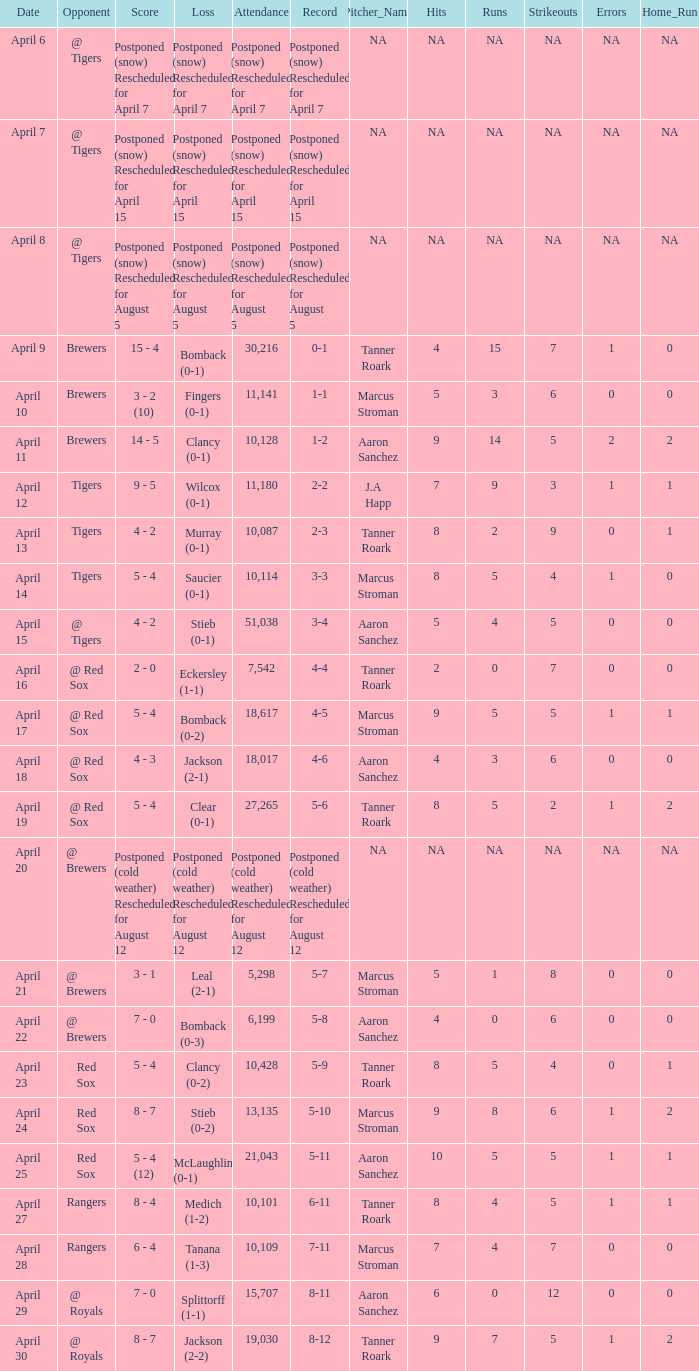Can you give me this table as a dict? {'header': ['Date', 'Opponent', 'Score', 'Loss', 'Attendance', 'Record', 'Pitcher_Name', 'Hits', 'Runs', 'Strikeouts', 'Errors', 'Home_Run'], 'rows': [['April 6', '@ Tigers', 'Postponed (snow) Rescheduled for April 7', 'Postponed (snow) Rescheduled for April 7', 'Postponed (snow) Rescheduled for April 7', 'Postponed (snow) Rescheduled for April 7', 'NA', 'NA', 'NA', 'NA', 'NA', 'NA'], ['April 7', '@ Tigers', 'Postponed (snow) Rescheduled for April 15', 'Postponed (snow) Rescheduled for April 15', 'Postponed (snow) Rescheduled for April 15', 'Postponed (snow) Rescheduled for April 15', 'NA', 'NA', 'NA', 'NA', 'NA', 'NA'], ['April 8', '@ Tigers', 'Postponed (snow) Rescheduled for August 5', 'Postponed (snow) Rescheduled for August 5', 'Postponed (snow) Rescheduled for August 5', 'Postponed (snow) Rescheduled for August 5', 'NA', 'NA', 'NA', 'NA', 'NA', 'NA'], ['April 9', 'Brewers', '15 - 4', 'Bomback (0-1)', '30,216', '0-1', 'Tanner Roark', '4', '15', '7', '1', '0'], ['April 10', 'Brewers', '3 - 2 (10)', 'Fingers (0-1)', '11,141', '1-1', 'Marcus Stroman', '5', '3', '6', '0', '0'], ['April 11', 'Brewers', '14 - 5', 'Clancy (0-1)', '10,128', '1-2', 'Aaron Sanchez', '9', '14', '5', '2', '2'], ['April 12', 'Tigers', '9 - 5', 'Wilcox (0-1)', '11,180', '2-2', 'J.A Happ', '7', '9', '3', '1', '1'], ['April 13', 'Tigers', '4 - 2', 'Murray (0-1)', '10,087', '2-3', 'Tanner Roark', '8', '2', '9', '0', '1'], ['April 14', 'Tigers', '5 - 4', 'Saucier (0-1)', '10,114', '3-3', 'Marcus Stroman', '8', '5', '4', '1', '0'], ['April 15', '@ Tigers', '4 - 2', 'Stieb (0-1)', '51,038', '3-4', 'Aaron Sanchez', '5', '4', '5', '0', '0'], ['April 16', '@ Red Sox', '2 - 0', 'Eckersley (1-1)', '7,542', '4-4', 'Tanner Roark', '2', '0', '7', '0', '0'], ['April 17', '@ Red Sox', '5 - 4', 'Bomback (0-2)', '18,617', '4-5', 'Marcus Stroman', '9', '5', '5', '1', '1'], ['April 18', '@ Red Sox', '4 - 3', 'Jackson (2-1)', '18,017', '4-6', 'Aaron Sanchez', '4', '3', '6', '0', '0'], ['April 19', '@ Red Sox', '5 - 4', 'Clear (0-1)', '27,265', '5-6', 'Tanner Roark', '8', '5', '2', '1', '2'], ['April 20', '@ Brewers', 'Postponed (cold weather) Rescheduled for August 12', 'Postponed (cold weather) Rescheduled for August 12', 'Postponed (cold weather) Rescheduled for August 12', 'Postponed (cold weather) Rescheduled for August 12', 'NA', 'NA', 'NA', 'NA', 'NA', 'NA'], ['April 21', '@ Brewers', '3 - 1', 'Leal (2-1)', '5,298', '5-7', 'Marcus Stroman', '5', '1', '8', '0', '0'], ['April 22', '@ Brewers', '7 - 0', 'Bomback (0-3)', '6,199', '5-8', 'Aaron Sanchez', '4', '0', '6', '0', '0'], ['April 23', 'Red Sox', '5 - 4', 'Clancy (0-2)', '10,428', '5-9', 'Tanner Roark', '8', '5', '4', '0', '1'], ['April 24', 'Red Sox', '8 - 7', 'Stieb (0-2)', '13,135', '5-10', 'Marcus Stroman', '9', '8', '6', '1', '2'], ['April 25', 'Red Sox', '5 - 4 (12)', 'McLaughlin (0-1)', '21,043', '5-11', 'Aaron Sanchez', '10', '5', '5', '1', '1'], ['April 27', 'Rangers', '8 - 4', 'Medich (1-2)', '10,101', '6-11', 'Tanner Roark', '8', '4', '5', '1', '1'], ['April 28', 'Rangers', '6 - 4', 'Tanana (1-3)', '10,109', '7-11', 'Marcus Stroman', '7', '4', '7', '0', '0'], ['April 29', '@ Royals', '7 - 0', 'Splittorff (1-1)', '15,707', '8-11', 'Aaron Sanchez', '6', '0', '12', '0', '0'], ['April 30', '@ Royals', '8 - 7', 'Jackson (2-2)', '19,030', '8-12', 'Tanner Roark', '9', '7', '5', '1', '2']]} What was the date for the game that had an attendance of 10,101? April 27. 